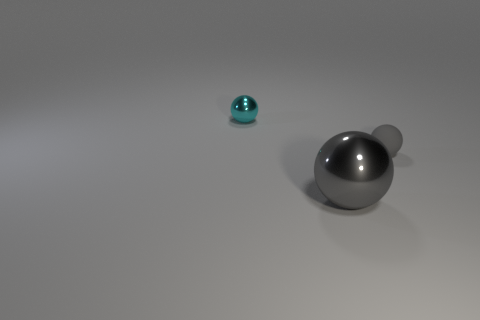Add 1 big cyan balls. How many objects exist? 4 Add 1 cyan metal things. How many cyan metal things are left? 2 Add 1 large rubber spheres. How many large rubber spheres exist? 1 Subtract 0 purple cylinders. How many objects are left? 3 Subtract all small purple matte balls. Subtract all small gray rubber objects. How many objects are left? 2 